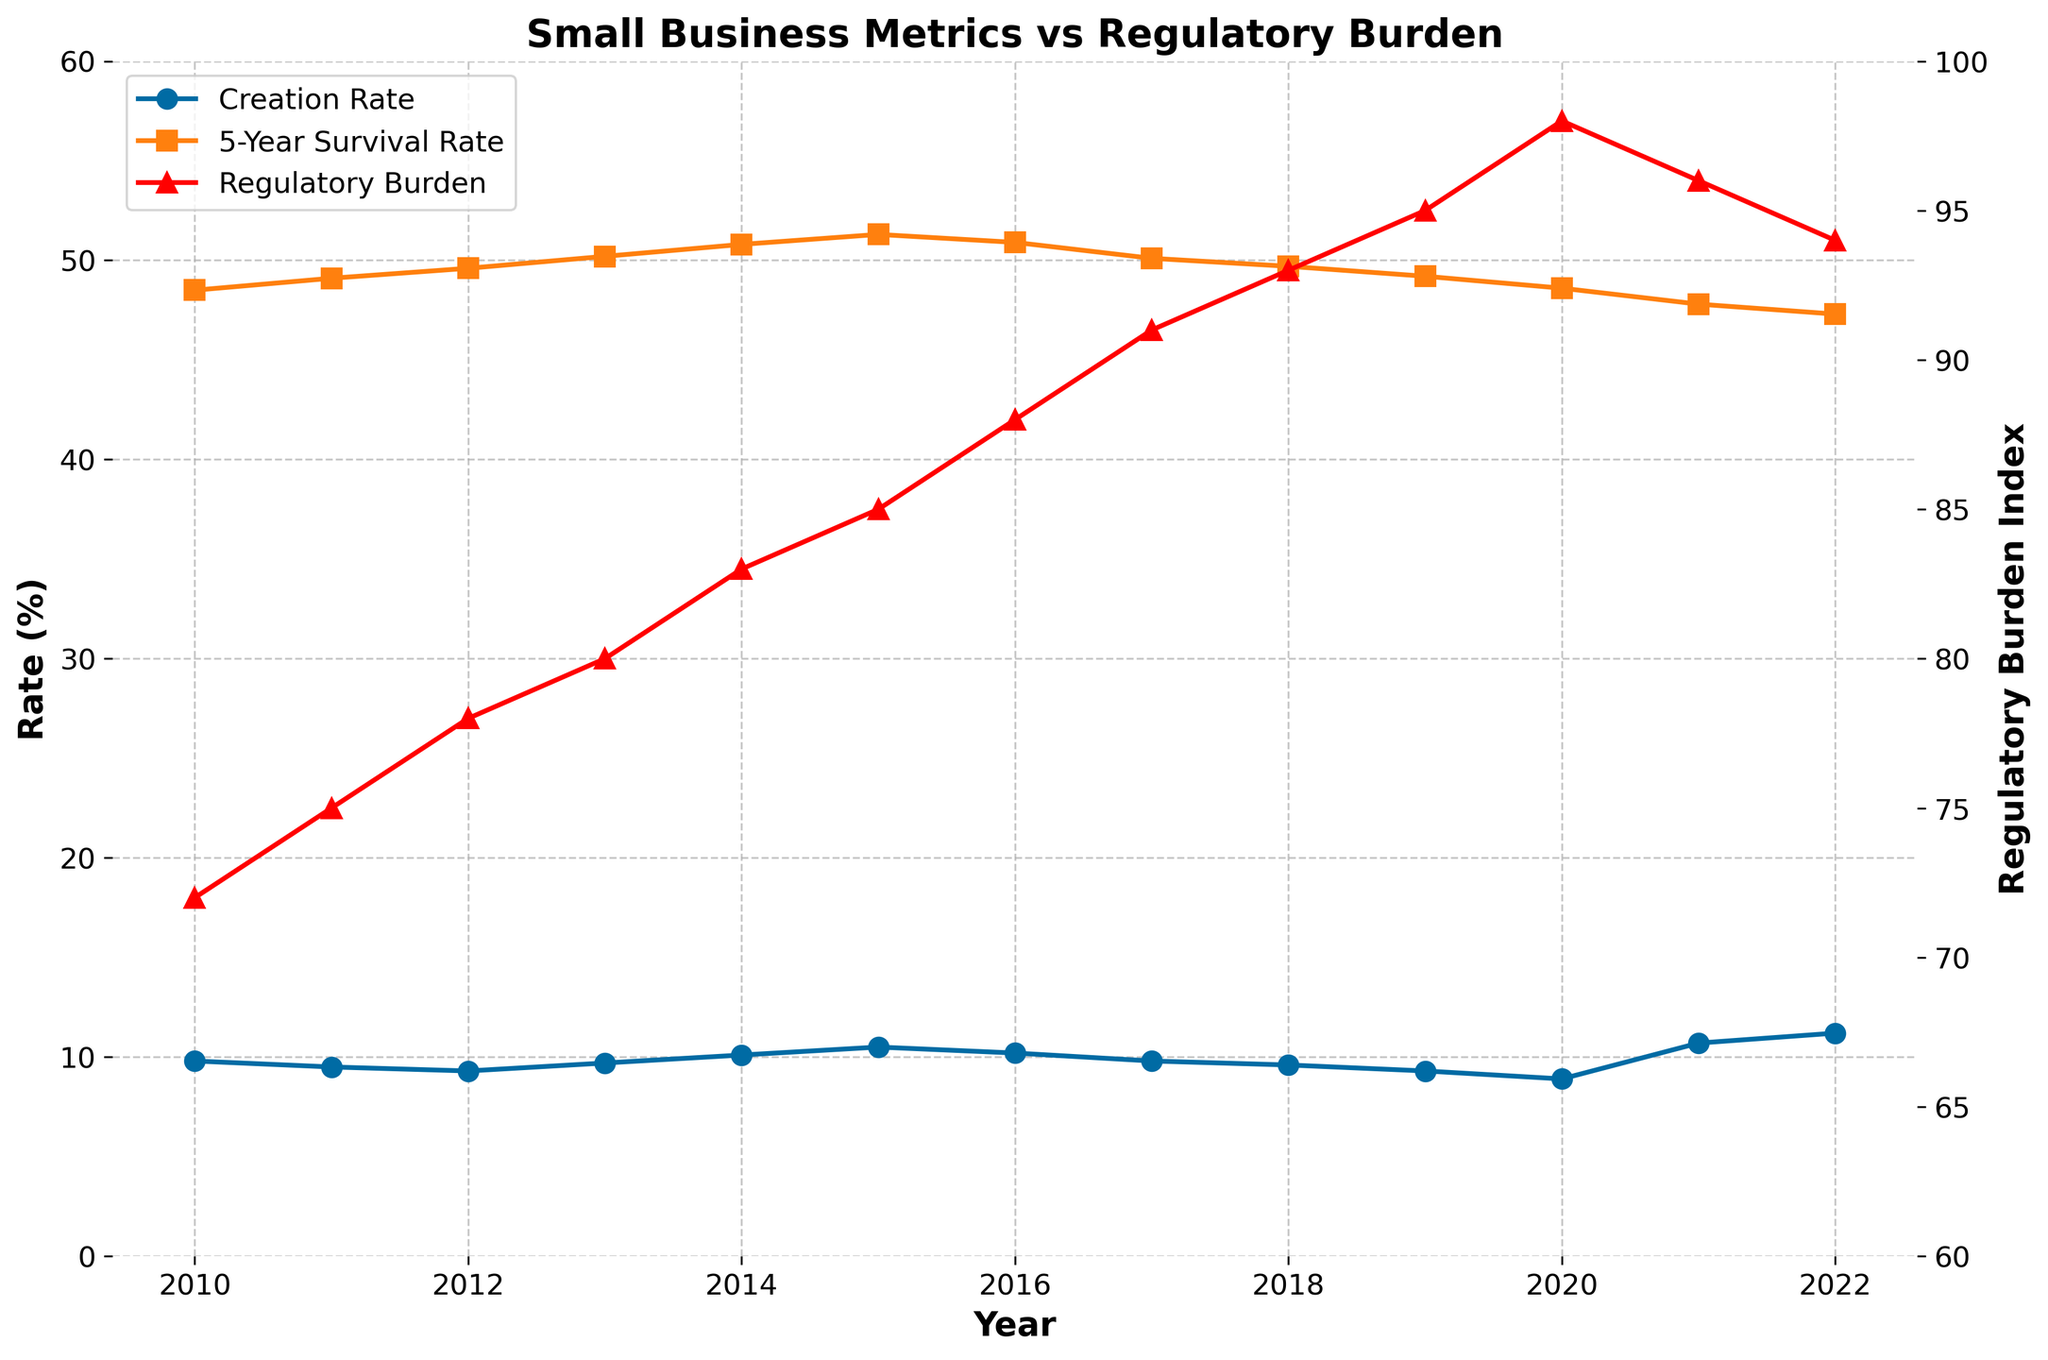What is the trend in the Small Business Creation Rate from 2010 to 2022? Observe the line representing the Small Business Creation Rate. It starts at 9.8% in 2010, fluctuates, and increases to 11.2% in 2022.
Answer: Increasing trend How does the Small Business 5-Year Survival Rate in 2022 compare to 2010? Look at the Small Business 5-Year Survival Rate for 2010 and 2022. It decreases from 48.5% in 2010 to 47.3% in 2022.
Answer: Decreased What is the shape of the trend in Regulatory Burden from 2010 to 2022? Examine the red line. It generally increases from 72 in 2010 to 98 in 2020, then slightly decreases to 94 in 2022.
Answer: Increasing then slightly decreasing In which year was the Regulatory Burden Index the highest, and what was its value? Find the peak point on the red line. The highest value occurs in 2020 at 98.
Answer: 2020, 98 Compare the Small Business Creation Rate and the Regulatory Burden Index in 2020. What do you observe? Look at both lines for 2020. The creation rate dips to 8.9% while the regulatory burden peaks at 98.
Answer: Creation Rate low, Regulatory Burden high What relationship can be inferred between the Small Business 5-Year Survival Rate and the Regulatory Burden Index over time? Observe both trends. Generally, as the Regulatory Burden increases, the Survival Rate shows a decreasing trend.
Answer: Inverse relationship How much did the Regulatory Burden Index change from 2010 to 2022? Subtract the Regulatory Burden Index for 2010 (72) from that of 2022 (94). The difference is 22.
Answer: 22 What visual cue indicates the Regulatory Burden Index on the chart? The Regulatory Burden Index is represented by a red line with triangle markers.
Answer: Red line with triangles Which year saw the highest Small Business Creation Rate, and what was this rate? Look for the peak on the creation rate line. The highest rate is in 2022 at 11.2%.
Answer: 2022, 11.2% 